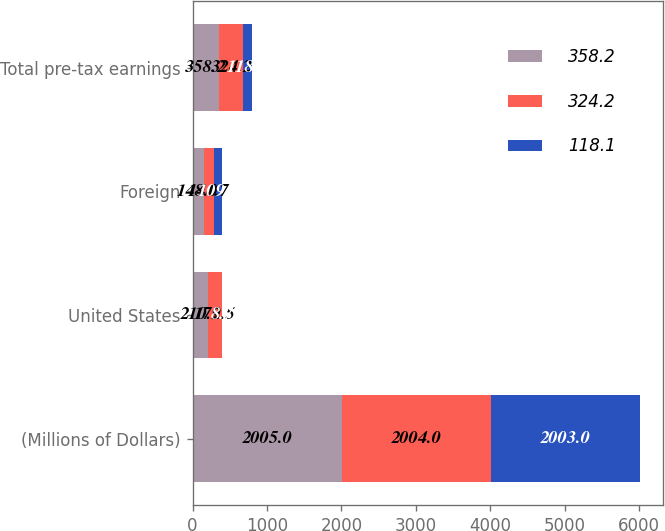Convert chart to OTSL. <chart><loc_0><loc_0><loc_500><loc_500><stacked_bar_chart><ecel><fcel>(Millions of Dollars)<fcel>United States<fcel>Foreign<fcel>Total pre-tax earnings<nl><fcel>358.2<fcel>2005<fcel>210.2<fcel>148<fcel>358.2<nl><fcel>324.2<fcel>2004<fcel>179.5<fcel>144.7<fcel>324.2<nl><fcel>118.1<fcel>2003<fcel>8.7<fcel>109.4<fcel>118.1<nl></chart> 